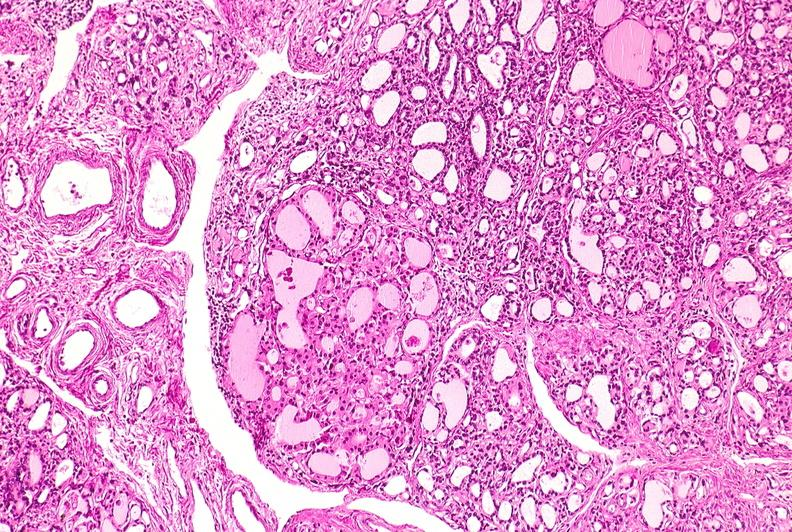s pus in test tube present?
Answer the question using a single word or phrase. No 